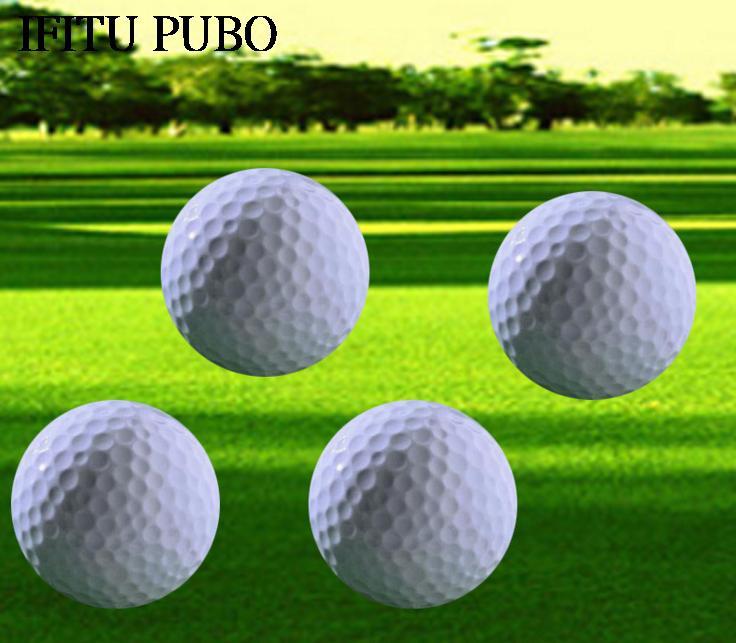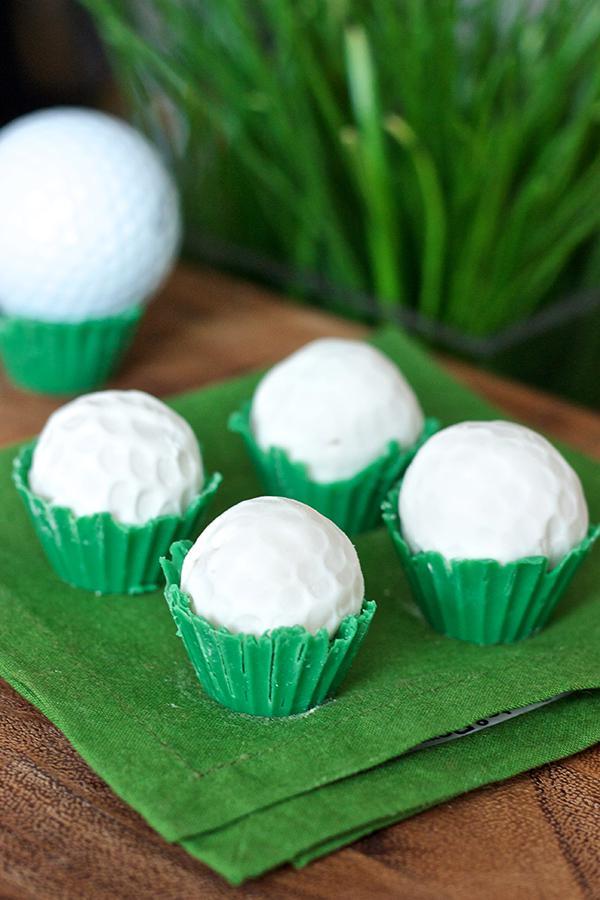The first image is the image on the left, the second image is the image on the right. Examine the images to the left and right. Is the description "One image contains a mass of all-white balls on green turf, most with no space between them." accurate? Answer yes or no. No. The first image is the image on the left, the second image is the image on the right. Given the left and right images, does the statement "There are exactly two golf balls in one of the images." hold true? Answer yes or no. No. 